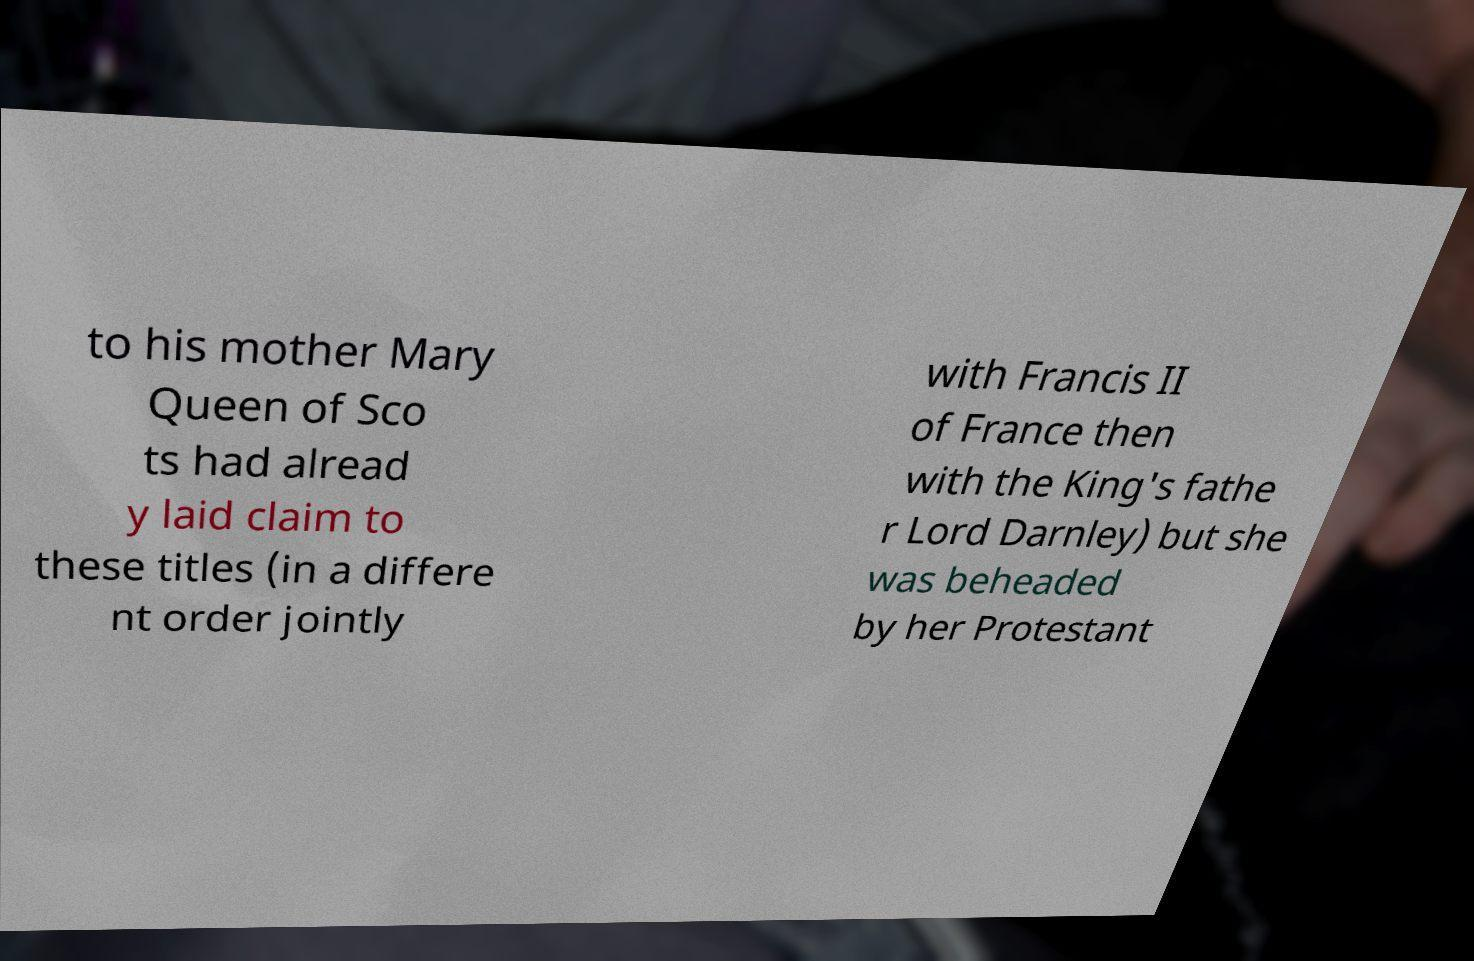Could you assist in decoding the text presented in this image and type it out clearly? to his mother Mary Queen of Sco ts had alread y laid claim to these titles (in a differe nt order jointly with Francis II of France then with the King's fathe r Lord Darnley) but she was beheaded by her Protestant 